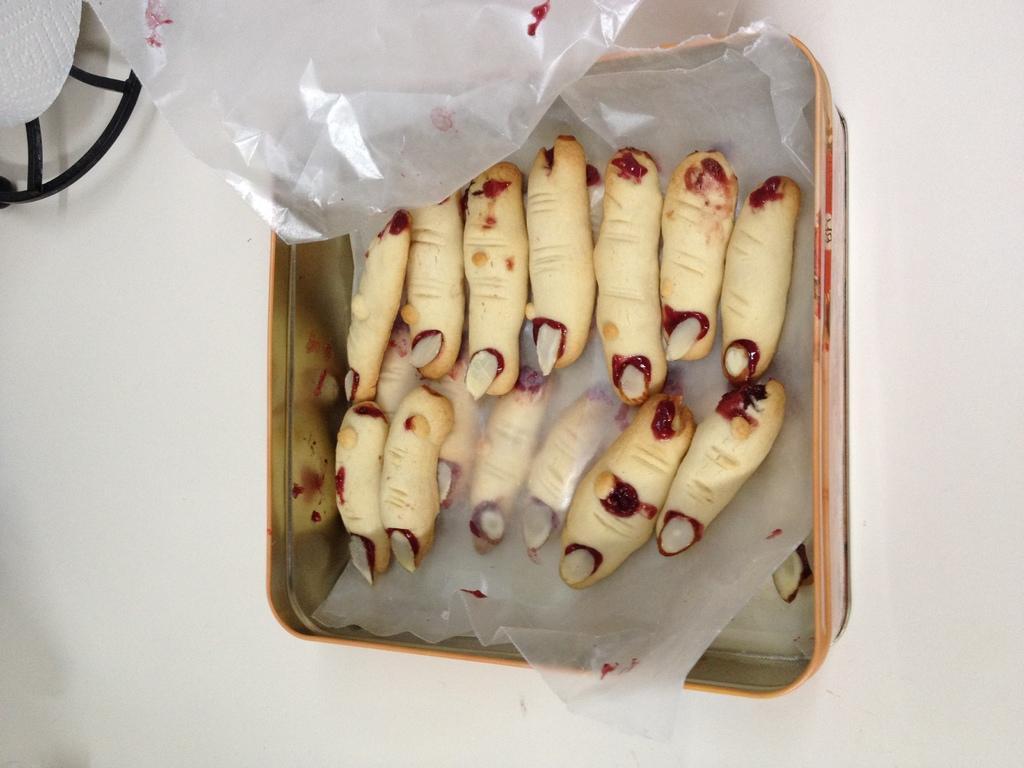Can you describe this image briefly? In this picture we can see food items in a box and this box is on a platform, where we can see polythene covers and an object. 